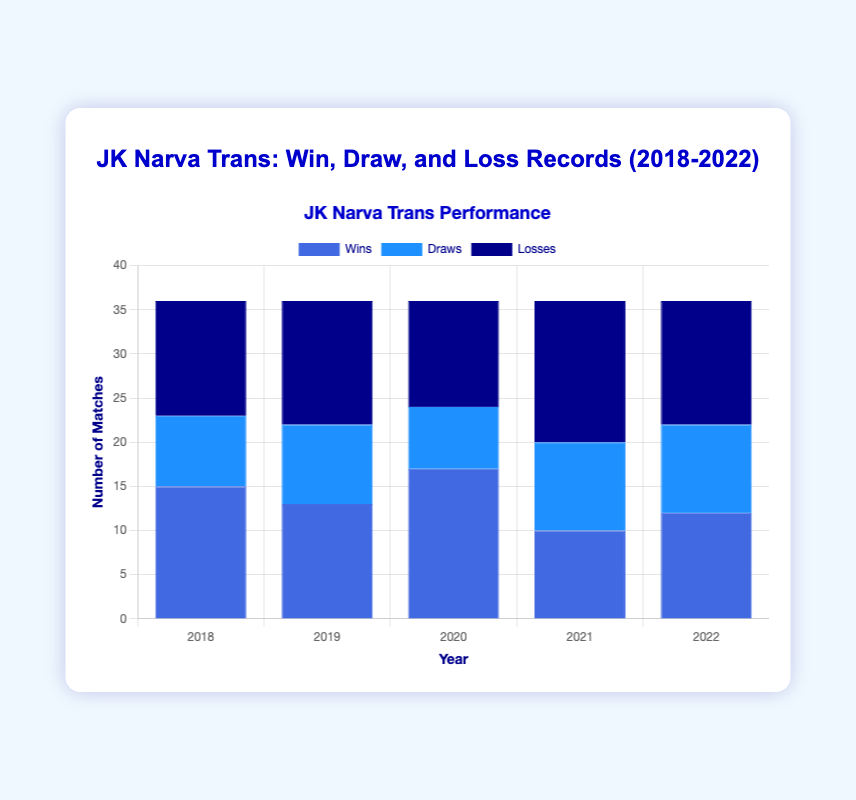Which year did JK Narva Trans have the highest number of wins? To determine the year with the highest number of wins, look at the bars labeled "Wins" for all years and identify which one is the tallest. The tallest "Wins" bar corresponds to the year 2020.
Answer: 2020 How many total matches (wins + draws + losses) did JK Narva Trans play in 2019? Add up the number of wins, draws, and losses for 2019: 13 (wins) + 9 (draws) + 14 (losses) = 36.
Answer: 36 In which year did JK Narva Trans have more losses compared to wins? Compare the height of the "Losses" bars to the "Wins" bars for each year. The years with more losses than wins are 2019, 2021, and 2022.
Answer: 2019, 2021, 2022 What is the combined total of wins in 2018 and 2022? Add the number of wins for 2018 and 2022: 15 (2018) + 12 (2022) = 27.
Answer: 27 Which year had the highest number of draws? Look at the bars labeled "Draws" and identify the year with the tallest bar. The highest number of draws (10) is in both 2021 and 2022.
Answer: 2021, 2022 Did JK Narva Trans experience more wins or losses in 2020? Compare the height of the "Wins" bar to the "Losses" bar for 2020. Wins (17) are greater than losses (12) in 2020.
Answer: Wins What is the average number of draws over the five years? Add up all the draws and divide by the number of years: (8 + 9 + 7 + 10 + 10) / 5 = 44 / 5 = 8.8.
Answer: 8.8 Compare the total number of wins in 2019 and 2021. What is the difference between the two years? Calculate the difference between the wins of 2019 and 2021: 13 (2019) - 10 (2021) = 3.
Answer: 3 Which year had the lowest total number of matches (wins + draws + losses) played? Calculate the total number of matches for each year and find the smallest sum. The totals are: 2018: 36, 2019: 36, 2020: 36, 2021: 36, 2022: 36. All years have an equal number of total matches, so no year has the lowest total.
Answer: All years are equal How does the number of losses in 2021 compare to the number of losses in 2018? Compare the height of the "Losses" bar in 2021 with 2018. Losses in 2021 (16) are greater than in 2018 (13).
Answer: 2021 > 2018 